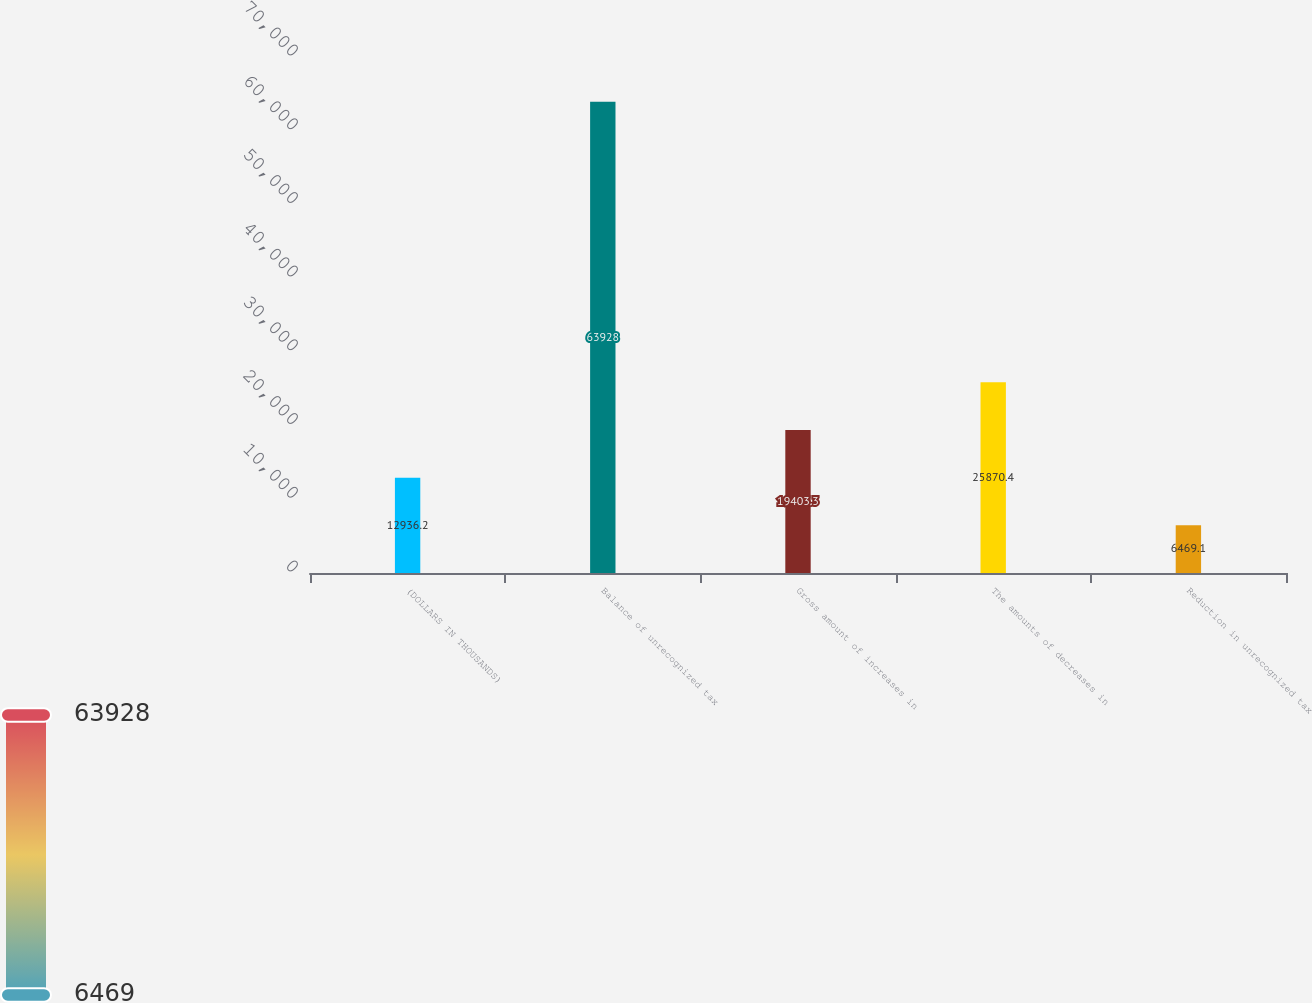<chart> <loc_0><loc_0><loc_500><loc_500><bar_chart><fcel>(DOLLARS IN THOUSANDS)<fcel>Balance of unrecognized tax<fcel>Gross amount of increases in<fcel>The amounts of decreases in<fcel>Reduction in unrecognized tax<nl><fcel>12936.2<fcel>63928<fcel>19403.3<fcel>25870.4<fcel>6469.1<nl></chart> 